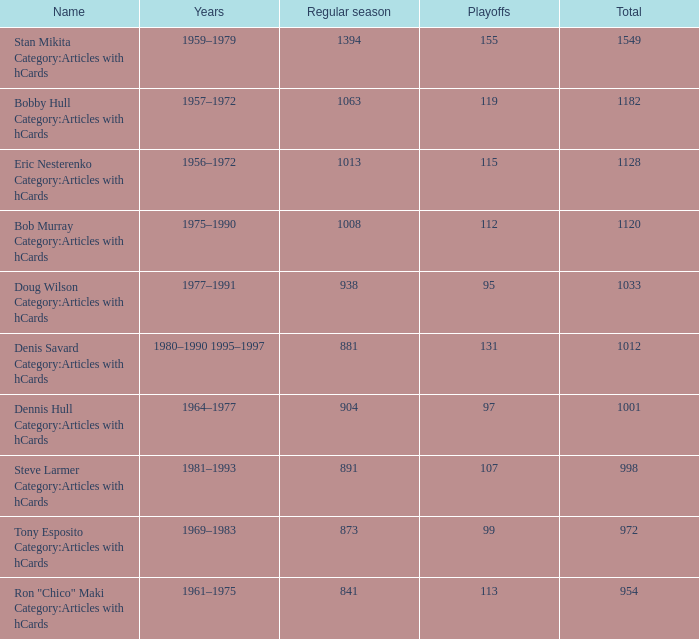What is the years when playoffs is 115? 1956–1972. 